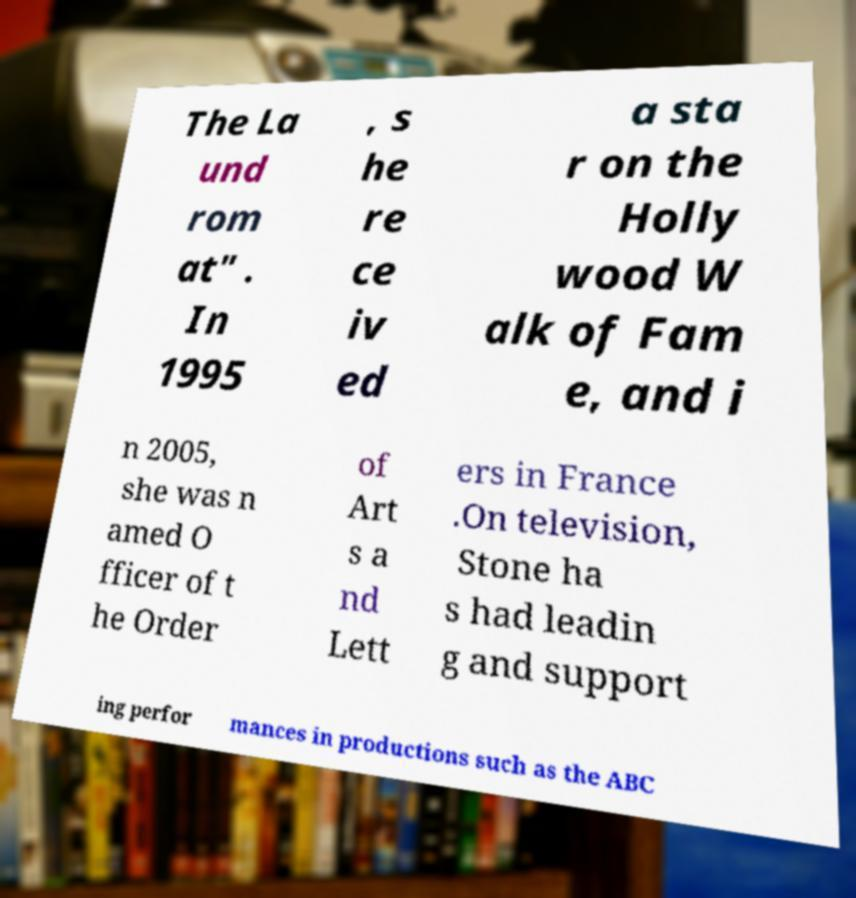For documentation purposes, I need the text within this image transcribed. Could you provide that? The La und rom at" . In 1995 , s he re ce iv ed a sta r on the Holly wood W alk of Fam e, and i n 2005, she was n amed O fficer of t he Order of Art s a nd Lett ers in France .On television, Stone ha s had leadin g and support ing perfor mances in productions such as the ABC 